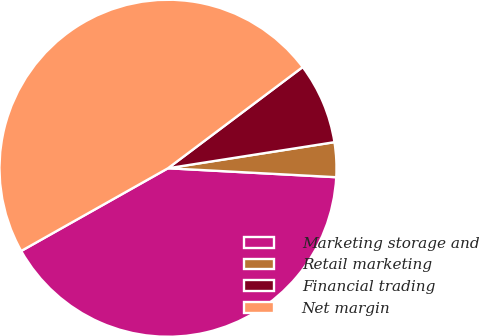Convert chart to OTSL. <chart><loc_0><loc_0><loc_500><loc_500><pie_chart><fcel>Marketing storage and<fcel>Retail marketing<fcel>Financial trading<fcel>Net margin<nl><fcel>40.98%<fcel>3.32%<fcel>7.78%<fcel>47.91%<nl></chart> 